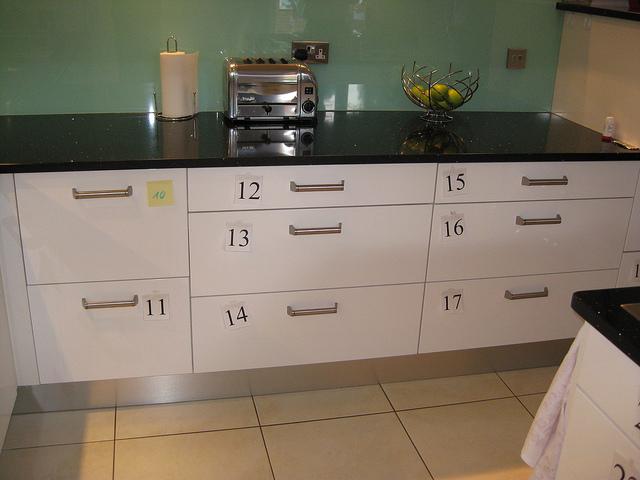Why do you think the drawers are numbered?
Be succinct. Organization. Is the floor tiled?
Short answer required. Yes. What is on top of the cabinet?
Concise answer only. Toaster. What is on the table?
Quick response, please. Toaster. What can you do with bread in this area?
Be succinct. Toast it. 